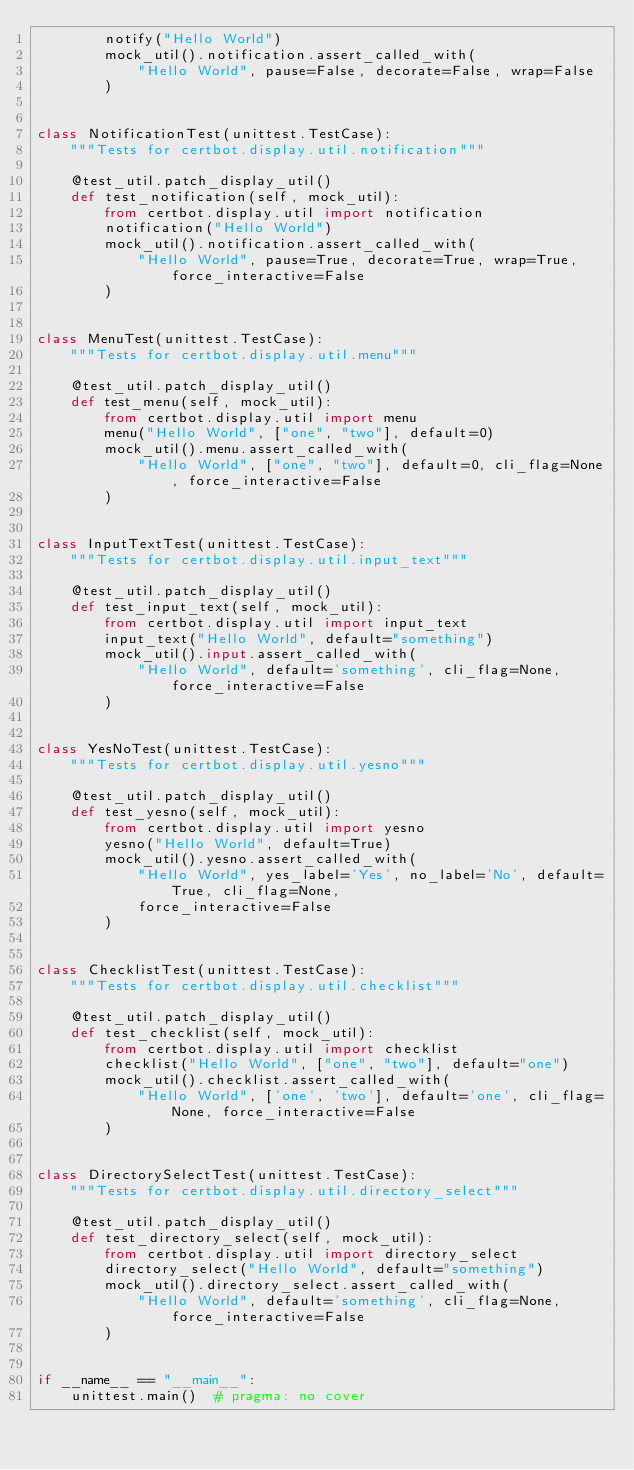Convert code to text. <code><loc_0><loc_0><loc_500><loc_500><_Python_>        notify("Hello World")
        mock_util().notification.assert_called_with(
            "Hello World", pause=False, decorate=False, wrap=False
        )


class NotificationTest(unittest.TestCase):
    """Tests for certbot.display.util.notification"""

    @test_util.patch_display_util()
    def test_notification(self, mock_util):
        from certbot.display.util import notification
        notification("Hello World")
        mock_util().notification.assert_called_with(
            "Hello World", pause=True, decorate=True, wrap=True, force_interactive=False
        )


class MenuTest(unittest.TestCase):
    """Tests for certbot.display.util.menu"""

    @test_util.patch_display_util()
    def test_menu(self, mock_util):
        from certbot.display.util import menu
        menu("Hello World", ["one", "two"], default=0)
        mock_util().menu.assert_called_with(
            "Hello World", ["one", "two"], default=0, cli_flag=None, force_interactive=False
        )


class InputTextTest(unittest.TestCase):
    """Tests for certbot.display.util.input_text"""

    @test_util.patch_display_util()
    def test_input_text(self, mock_util):
        from certbot.display.util import input_text
        input_text("Hello World", default="something")
        mock_util().input.assert_called_with(
            "Hello World", default='something', cli_flag=None, force_interactive=False
        )


class YesNoTest(unittest.TestCase):
    """Tests for certbot.display.util.yesno"""

    @test_util.patch_display_util()
    def test_yesno(self, mock_util):
        from certbot.display.util import yesno
        yesno("Hello World", default=True)
        mock_util().yesno.assert_called_with(
            "Hello World", yes_label='Yes', no_label='No', default=True, cli_flag=None,
            force_interactive=False
        )


class ChecklistTest(unittest.TestCase):
    """Tests for certbot.display.util.checklist"""

    @test_util.patch_display_util()
    def test_checklist(self, mock_util):
        from certbot.display.util import checklist
        checklist("Hello World", ["one", "two"], default="one")
        mock_util().checklist.assert_called_with(
            "Hello World", ['one', 'two'], default='one', cli_flag=None, force_interactive=False
        )


class DirectorySelectTest(unittest.TestCase):
    """Tests for certbot.display.util.directory_select"""

    @test_util.patch_display_util()
    def test_directory_select(self, mock_util):
        from certbot.display.util import directory_select
        directory_select("Hello World", default="something")
        mock_util().directory_select.assert_called_with(
            "Hello World", default='something', cli_flag=None, force_interactive=False
        )


if __name__ == "__main__":
    unittest.main()  # pragma: no cover
</code> 